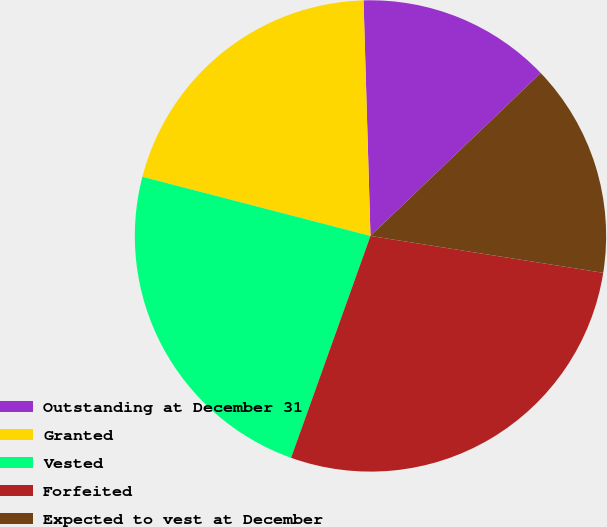Convert chart to OTSL. <chart><loc_0><loc_0><loc_500><loc_500><pie_chart><fcel>Outstanding at December 31<fcel>Granted<fcel>Vested<fcel>Forfeited<fcel>Expected to vest at December<nl><fcel>13.32%<fcel>20.49%<fcel>23.57%<fcel>27.97%<fcel>14.65%<nl></chart> 